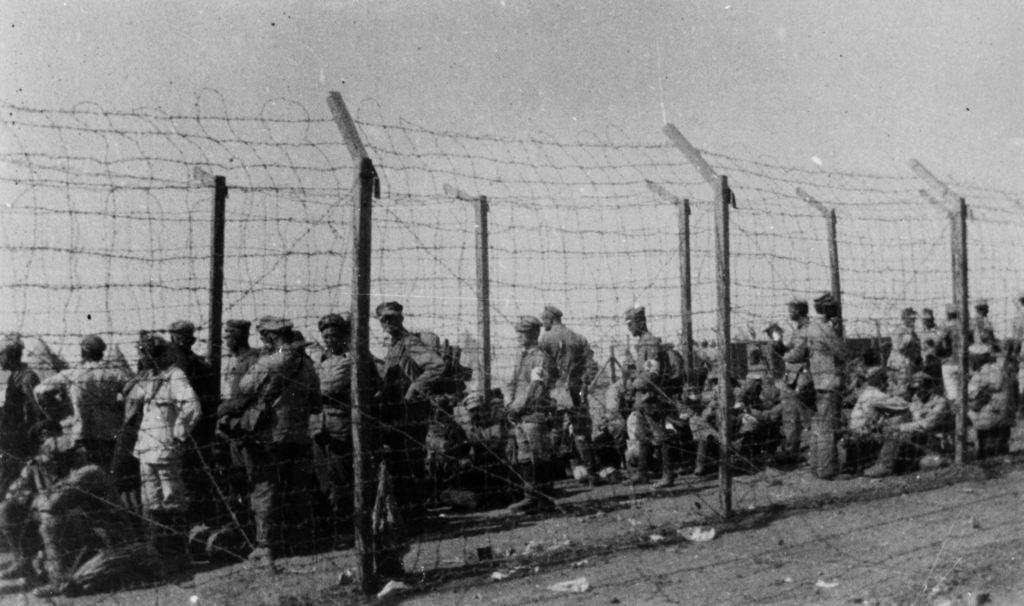In one or two sentences, can you explain what this image depicts? In this picture I can see there are a group of people standing and there is a fence and on the ground there is black soil and this is a black and white picture. The sky is clear. 